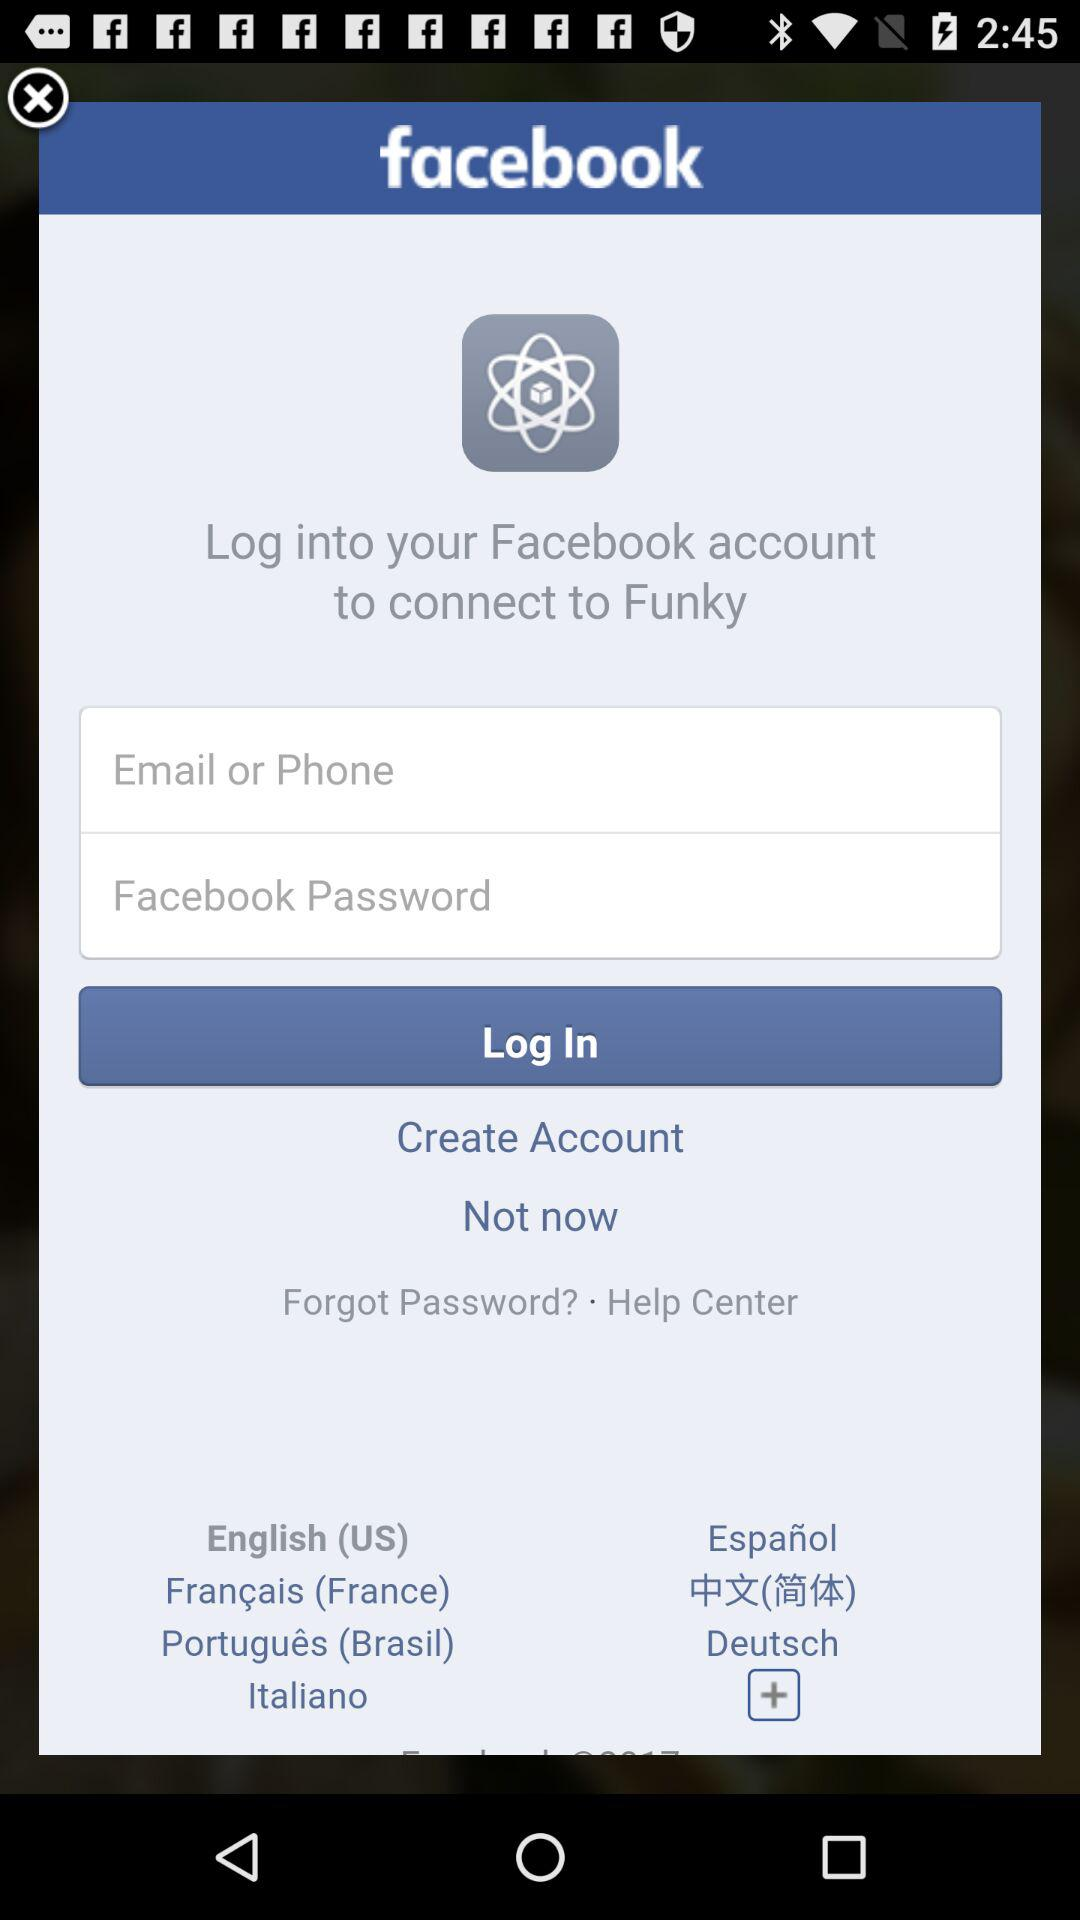Which language is selected? The selected language is English (US). 